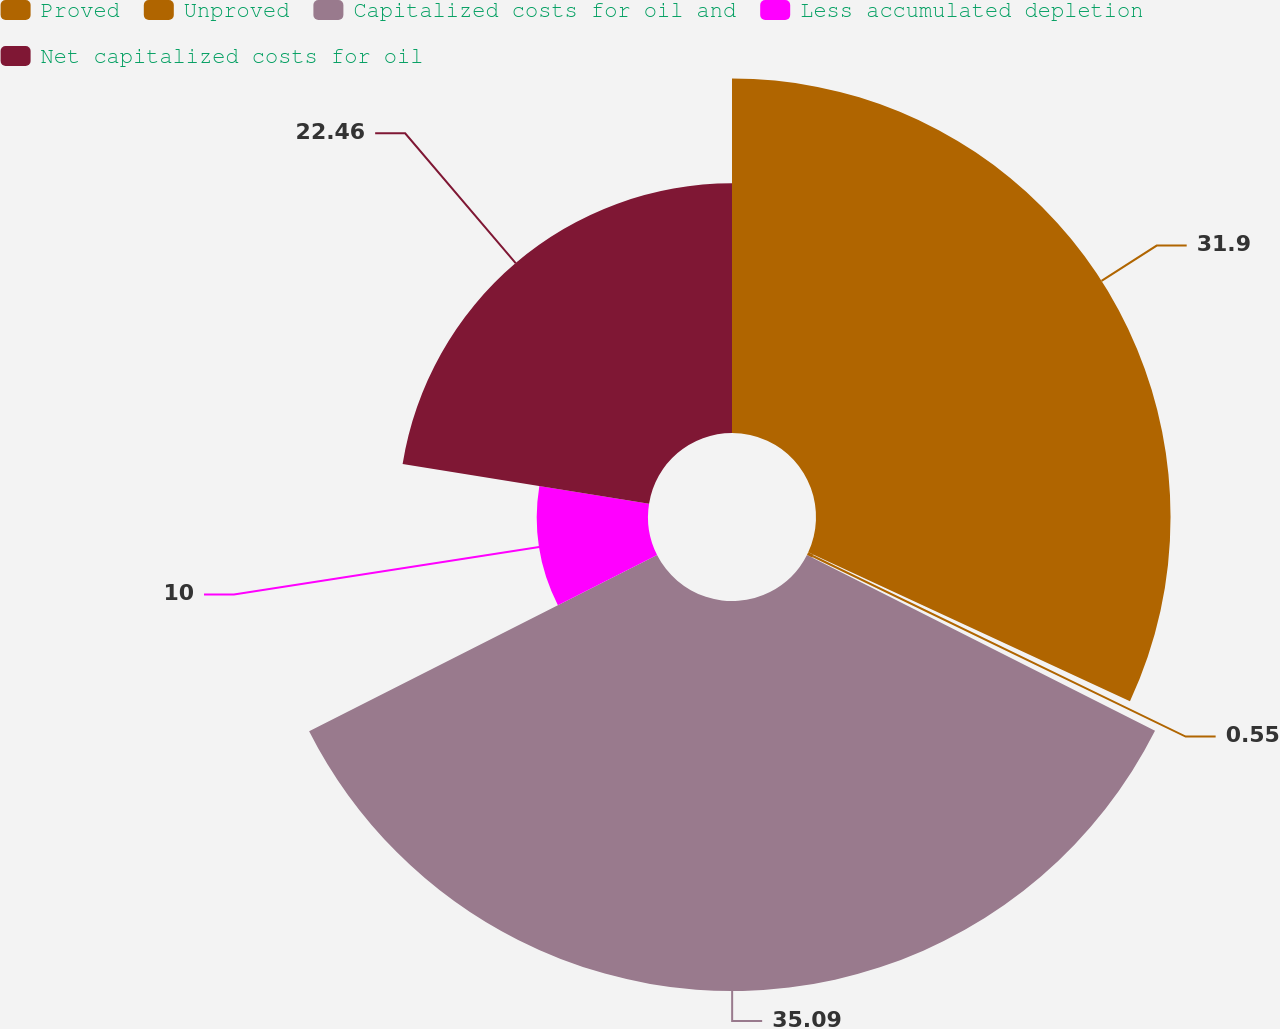Convert chart. <chart><loc_0><loc_0><loc_500><loc_500><pie_chart><fcel>Proved<fcel>Unproved<fcel>Capitalized costs for oil and<fcel>Less accumulated depletion<fcel>Net capitalized costs for oil<nl><fcel>31.9%<fcel>0.55%<fcel>35.09%<fcel>10.0%<fcel>22.46%<nl></chart> 